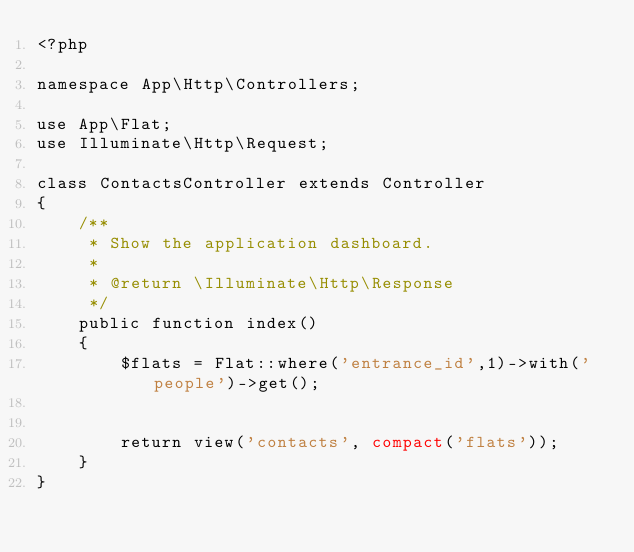Convert code to text. <code><loc_0><loc_0><loc_500><loc_500><_PHP_><?php

namespace App\Http\Controllers;

use App\Flat;
use Illuminate\Http\Request;

class ContactsController extends Controller
{
    /**
     * Show the application dashboard.
     *
     * @return \Illuminate\Http\Response
     */
    public function index()
    {
        $flats = Flat::where('entrance_id',1)->with('people')->get();


        return view('contacts', compact('flats'));
    }
}
</code> 